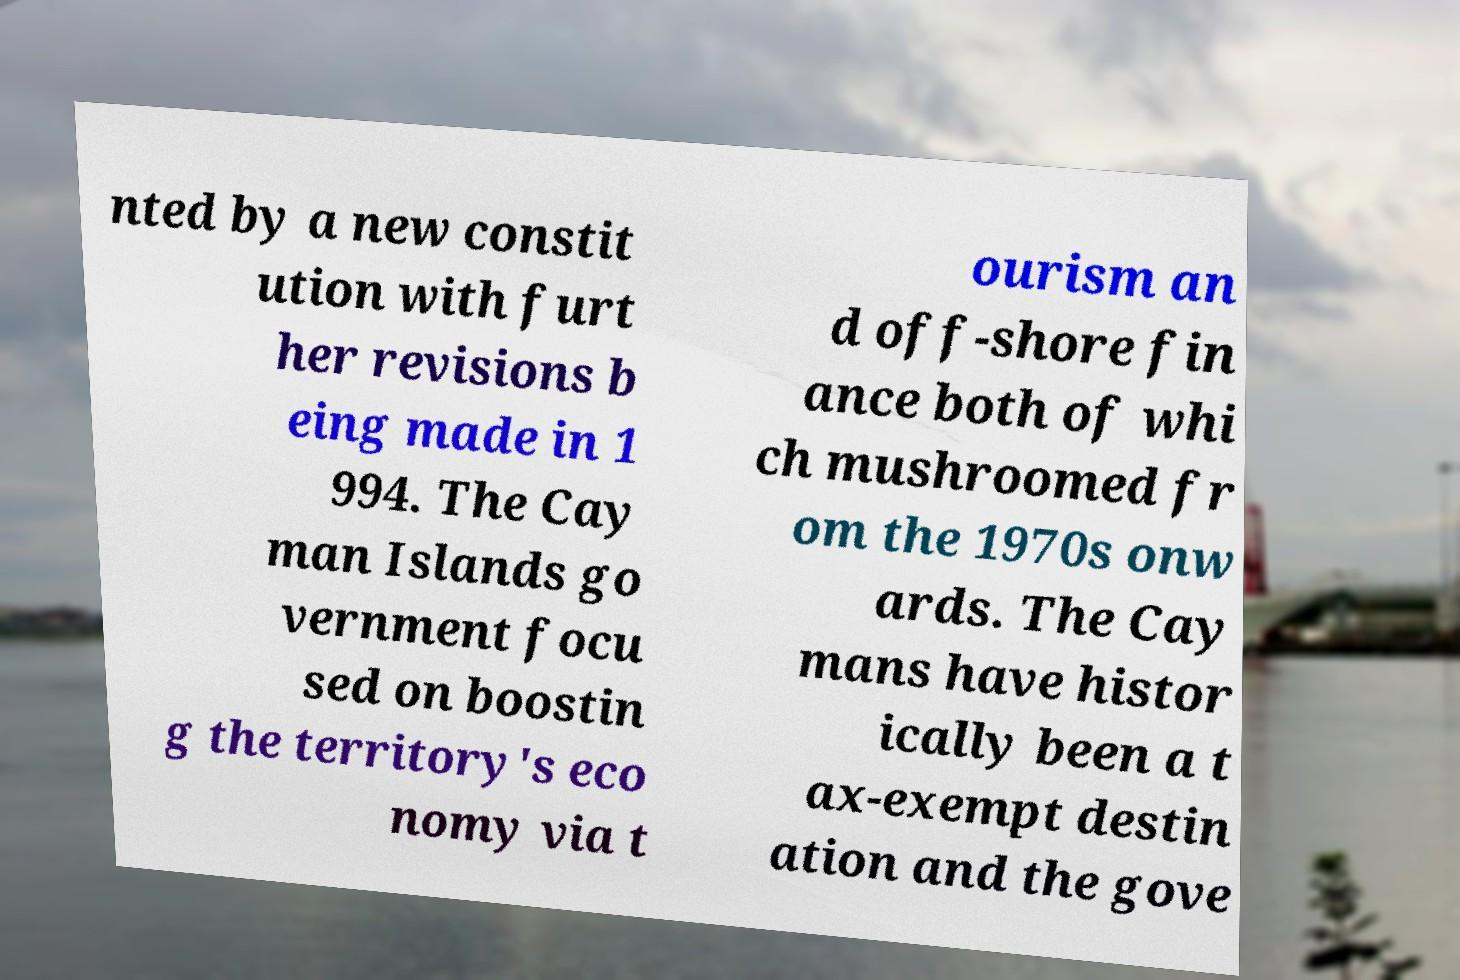For documentation purposes, I need the text within this image transcribed. Could you provide that? nted by a new constit ution with furt her revisions b eing made in 1 994. The Cay man Islands go vernment focu sed on boostin g the territory's eco nomy via t ourism an d off-shore fin ance both of whi ch mushroomed fr om the 1970s onw ards. The Cay mans have histor ically been a t ax-exempt destin ation and the gove 